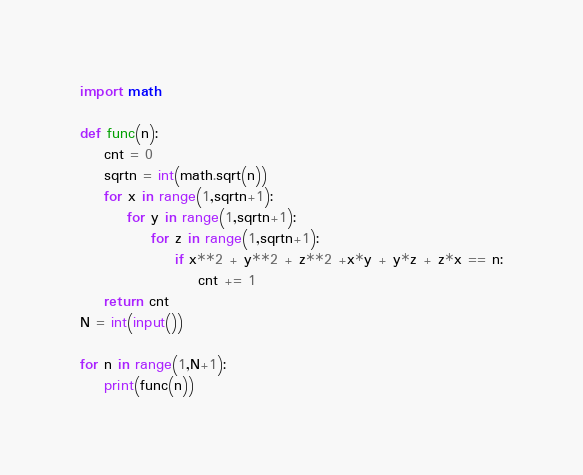<code> <loc_0><loc_0><loc_500><loc_500><_Python_>import math
 
def func(n):
    cnt = 0
    sqrtn = int(math.sqrt(n))
    for x in range(1,sqrtn+1):
        for y in range(1,sqrtn+1):
            for z in range(1,sqrtn+1):
                if x**2 + y**2 + z**2 +x*y + y*z + z*x == n:
                    cnt += 1
    return cnt
N = int(input())
 
for n in range(1,N+1):
    print(func(n))</code> 